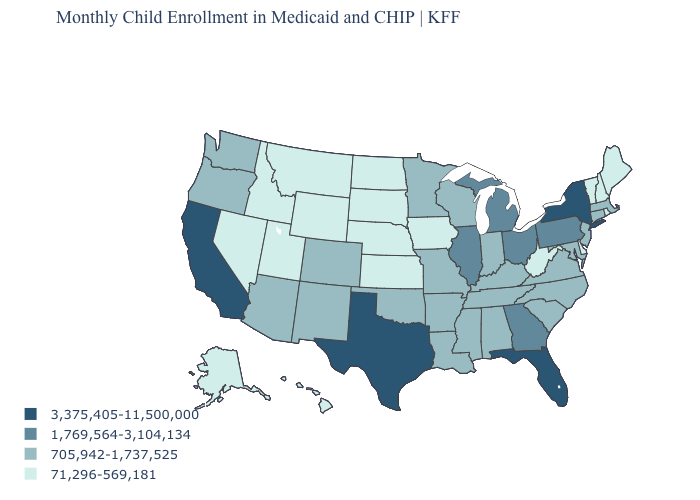What is the lowest value in the Northeast?
Be succinct. 71,296-569,181. What is the value of Idaho?
Be succinct. 71,296-569,181. Name the states that have a value in the range 71,296-569,181?
Give a very brief answer. Alaska, Delaware, Hawaii, Idaho, Iowa, Kansas, Maine, Montana, Nebraska, Nevada, New Hampshire, North Dakota, Rhode Island, South Dakota, Utah, Vermont, West Virginia, Wyoming. Name the states that have a value in the range 71,296-569,181?
Give a very brief answer. Alaska, Delaware, Hawaii, Idaho, Iowa, Kansas, Maine, Montana, Nebraska, Nevada, New Hampshire, North Dakota, Rhode Island, South Dakota, Utah, Vermont, West Virginia, Wyoming. Does the map have missing data?
Answer briefly. No. Name the states that have a value in the range 1,769,564-3,104,134?
Be succinct. Georgia, Illinois, Michigan, Ohio, Pennsylvania. Which states have the lowest value in the Northeast?
Answer briefly. Maine, New Hampshire, Rhode Island, Vermont. Name the states that have a value in the range 3,375,405-11,500,000?
Keep it brief. California, Florida, New York, Texas. Does Colorado have a higher value than Utah?
Answer briefly. Yes. Does South Carolina have a lower value than Texas?
Give a very brief answer. Yes. Does the map have missing data?
Be succinct. No. Name the states that have a value in the range 3,375,405-11,500,000?
Give a very brief answer. California, Florida, New York, Texas. Is the legend a continuous bar?
Give a very brief answer. No. Which states have the lowest value in the MidWest?
Short answer required. Iowa, Kansas, Nebraska, North Dakota, South Dakota. Which states have the lowest value in the South?
Give a very brief answer. Delaware, West Virginia. 